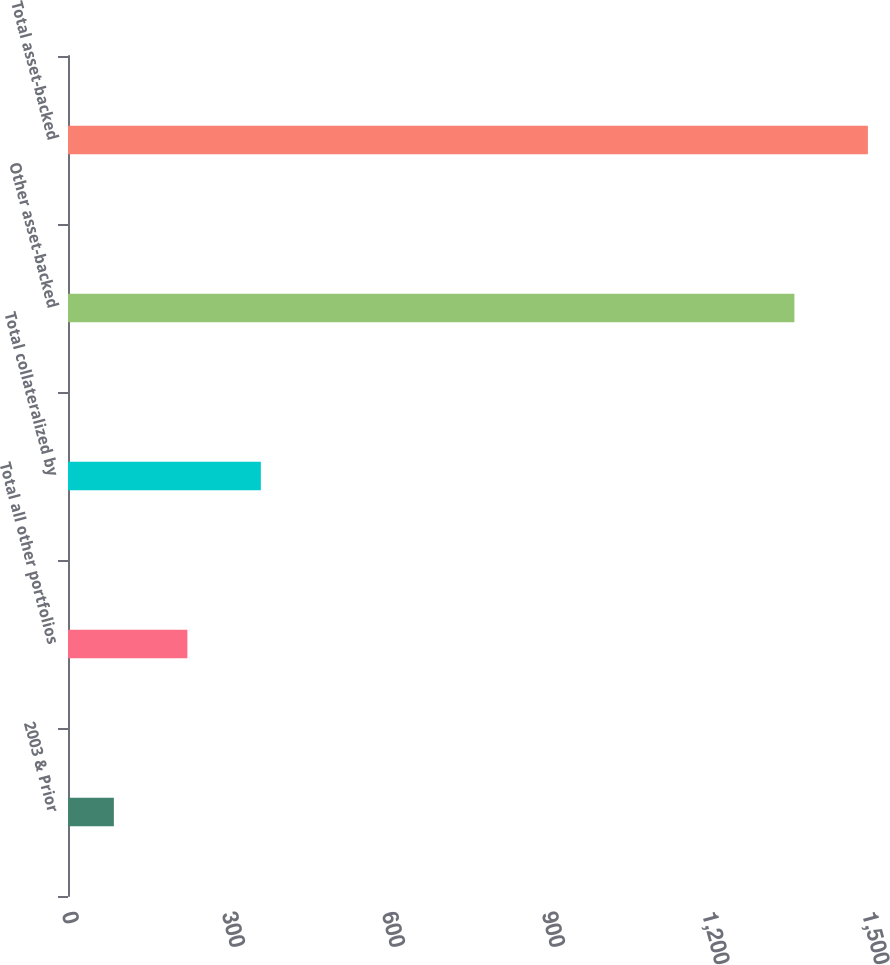<chart> <loc_0><loc_0><loc_500><loc_500><bar_chart><fcel>2003 & Prior<fcel>Total all other portfolios<fcel>Total collateralized by<fcel>Other asset-backed<fcel>Total asset-backed<nl><fcel>86<fcel>223.8<fcel>361.6<fcel>1362<fcel>1499.8<nl></chart> 